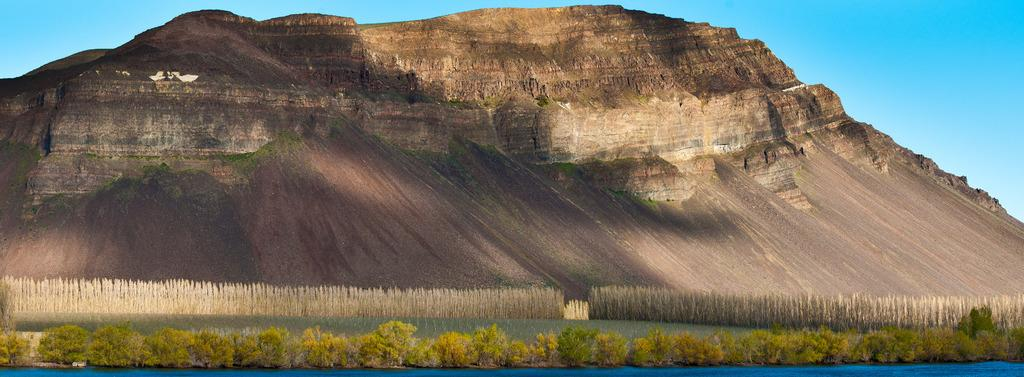What type of landscape can be seen in the picture? There are hills in the picture. What is located at the bottom of the picture? There are plants at the bottom of the picture. What can be seen in the sky in the picture? There are clouds in the sky. How many ants can be seen carrying insurance policies in the picture? There are no ants or insurance policies present in the picture. 